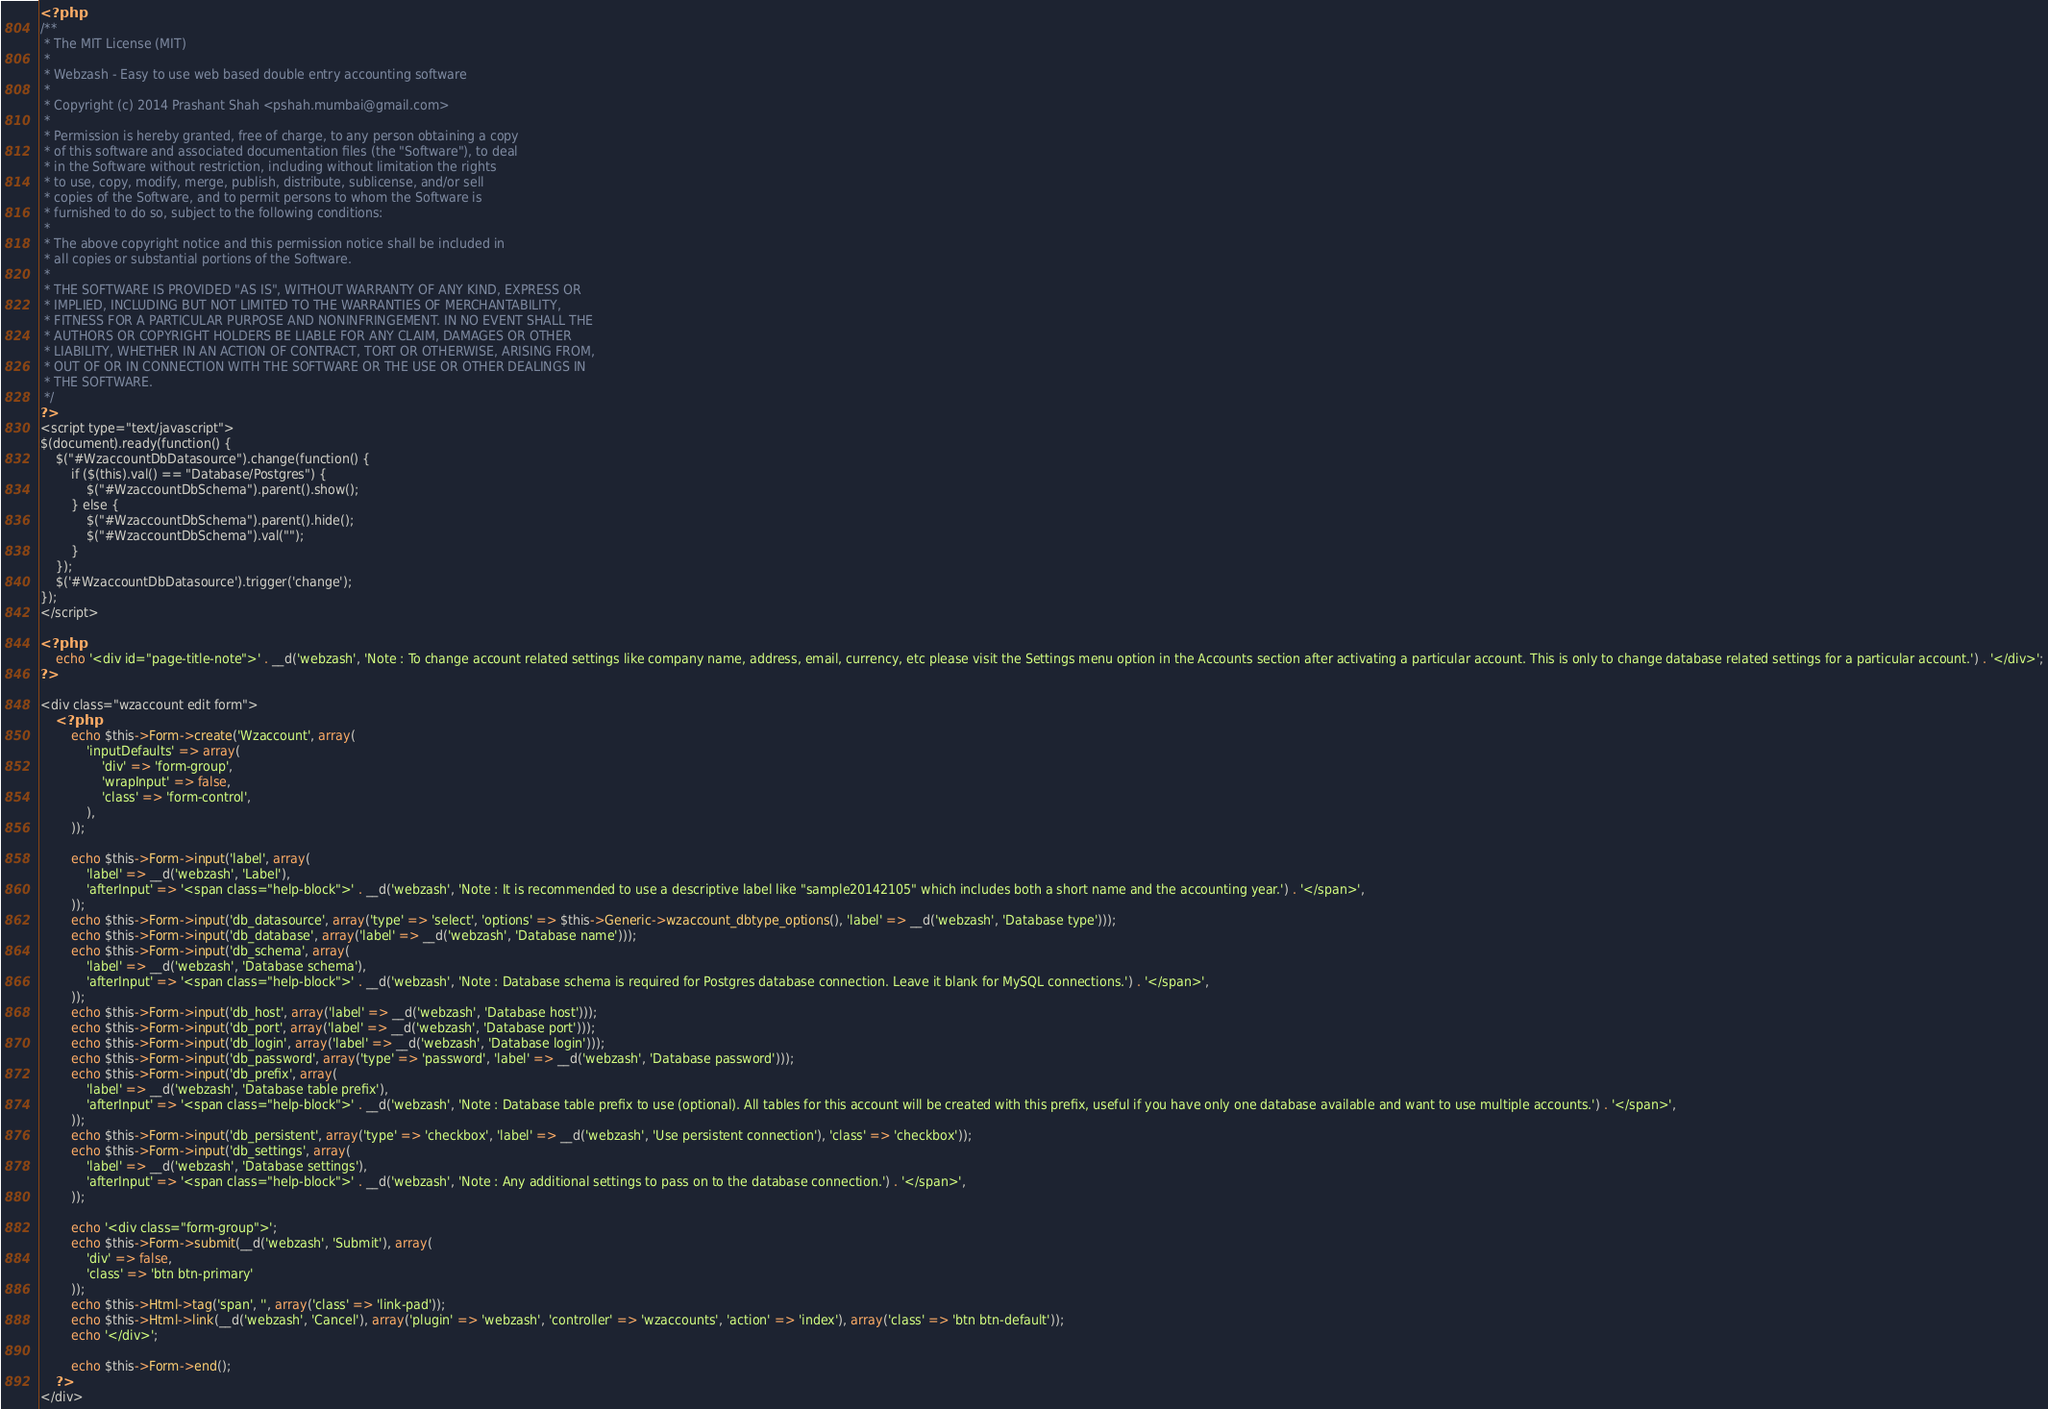<code> <loc_0><loc_0><loc_500><loc_500><_PHP_><?php
/**
 * The MIT License (MIT)
 *
 * Webzash - Easy to use web based double entry accounting software
 *
 * Copyright (c) 2014 Prashant Shah <pshah.mumbai@gmail.com>
 *
 * Permission is hereby granted, free of charge, to any person obtaining a copy
 * of this software and associated documentation files (the "Software"), to deal
 * in the Software without restriction, including without limitation the rights
 * to use, copy, modify, merge, publish, distribute, sublicense, and/or sell
 * copies of the Software, and to permit persons to whom the Software is
 * furnished to do so, subject to the following conditions:
 *
 * The above copyright notice and this permission notice shall be included in
 * all copies or substantial portions of the Software.
 *
 * THE SOFTWARE IS PROVIDED "AS IS", WITHOUT WARRANTY OF ANY KIND, EXPRESS OR
 * IMPLIED, INCLUDING BUT NOT LIMITED TO THE WARRANTIES OF MERCHANTABILITY,
 * FITNESS FOR A PARTICULAR PURPOSE AND NONINFRINGEMENT. IN NO EVENT SHALL THE
 * AUTHORS OR COPYRIGHT HOLDERS BE LIABLE FOR ANY CLAIM, DAMAGES OR OTHER
 * LIABILITY, WHETHER IN AN ACTION OF CONTRACT, TORT OR OTHERWISE, ARISING FROM,
 * OUT OF OR IN CONNECTION WITH THE SOFTWARE OR THE USE OR OTHER DEALINGS IN
 * THE SOFTWARE.
 */
?>
<script type="text/javascript">
$(document).ready(function() {
	$("#WzaccountDbDatasource").change(function() {
		if ($(this).val() == "Database/Postgres") {
			$("#WzaccountDbSchema").parent().show();
		} else {
			$("#WzaccountDbSchema").parent().hide();
			$("#WzaccountDbSchema").val("");
		}
	});
	$('#WzaccountDbDatasource').trigger('change');
});
</script>

<?php
	echo '<div id="page-title-note">' . __d('webzash', 'Note : To change account related settings like company name, address, email, currency, etc please visit the Settings menu option in the Accounts section after activating a particular account. This is only to change database related settings for a particular account.') . '</div>';
?>

<div class="wzaccount edit form">
	<?php
		echo $this->Form->create('Wzaccount', array(
			'inputDefaults' => array(
				'div' => 'form-group',
				'wrapInput' => false,
				'class' => 'form-control',
			),
		));

		echo $this->Form->input('label', array(
			'label' => __d('webzash', 'Label'),
			'afterInput' => '<span class="help-block">' . __d('webzash', 'Note : It is recommended to use a descriptive label like "sample20142105" which includes both a short name and the accounting year.') . '</span>',
		));
		echo $this->Form->input('db_datasource', array('type' => 'select', 'options' => $this->Generic->wzaccount_dbtype_options(), 'label' => __d('webzash', 'Database type')));
		echo $this->Form->input('db_database', array('label' => __d('webzash', 'Database name')));
		echo $this->Form->input('db_schema', array(
			'label' => __d('webzash', 'Database schema'),
			'afterInput' => '<span class="help-block">' . __d('webzash', 'Note : Database schema is required for Postgres database connection. Leave it blank for MySQL connections.') . '</span>',
		));
		echo $this->Form->input('db_host', array('label' => __d('webzash', 'Database host')));
		echo $this->Form->input('db_port', array('label' => __d('webzash', 'Database port')));
		echo $this->Form->input('db_login', array('label' => __d('webzash', 'Database login')));
		echo $this->Form->input('db_password', array('type' => 'password', 'label' => __d('webzash', 'Database password')));
		echo $this->Form->input('db_prefix', array(
			'label' => __d('webzash', 'Database table prefix'),
			'afterInput' => '<span class="help-block">' . __d('webzash', 'Note : Database table prefix to use (optional). All tables for this account will be created with this prefix, useful if you have only one database available and want to use multiple accounts.') . '</span>',
		));
		echo $this->Form->input('db_persistent', array('type' => 'checkbox', 'label' => __d('webzash', 'Use persistent connection'), 'class' => 'checkbox'));
		echo $this->Form->input('db_settings', array(
			'label' => __d('webzash', 'Database settings'),
			'afterInput' => '<span class="help-block">' . __d('webzash', 'Note : Any additional settings to pass on to the database connection.') . '</span>',
		));

		echo '<div class="form-group">';
		echo $this->Form->submit(__d('webzash', 'Submit'), array(
			'div' => false,
			'class' => 'btn btn-primary'
		));
		echo $this->Html->tag('span', '', array('class' => 'link-pad'));
		echo $this->Html->link(__d('webzash', 'Cancel'), array('plugin' => 'webzash', 'controller' => 'wzaccounts', 'action' => 'index'), array('class' => 'btn btn-default'));
		echo '</div>';

		echo $this->Form->end();
	?>
</div>
</code> 